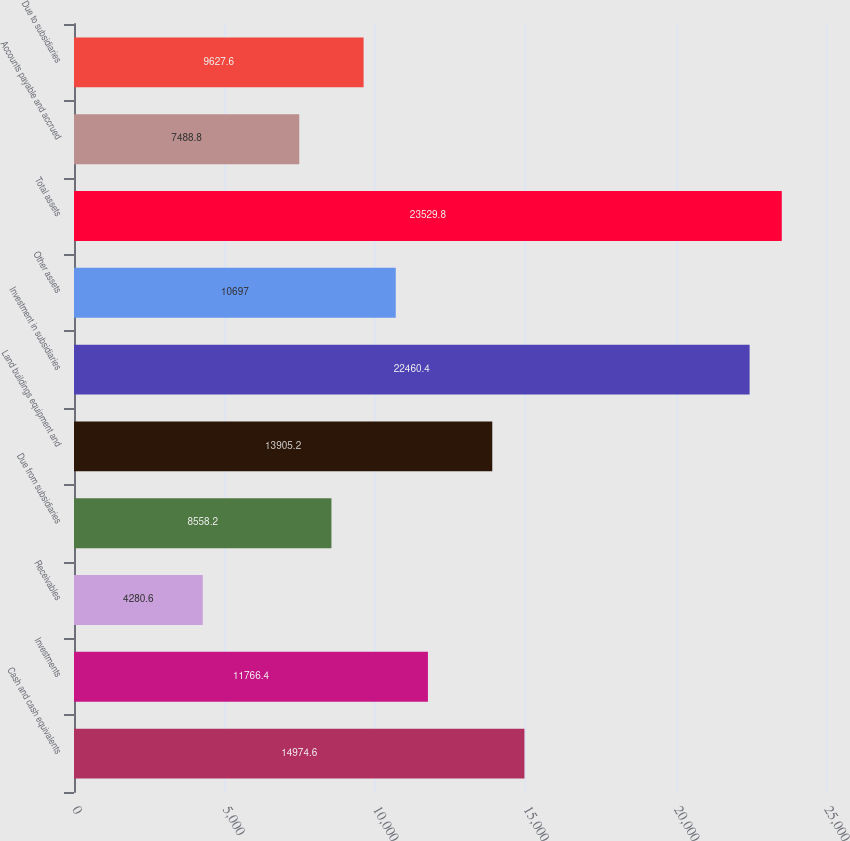Convert chart to OTSL. <chart><loc_0><loc_0><loc_500><loc_500><bar_chart><fcel>Cash and cash equivalents<fcel>Investments<fcel>Receivables<fcel>Due from subsidiaries<fcel>Land buildings equipment and<fcel>Investment in subsidiaries<fcel>Other assets<fcel>Total assets<fcel>Accounts payable and accrued<fcel>Due to subsidiaries<nl><fcel>14974.6<fcel>11766.4<fcel>4280.6<fcel>8558.2<fcel>13905.2<fcel>22460.4<fcel>10697<fcel>23529.8<fcel>7488.8<fcel>9627.6<nl></chart> 